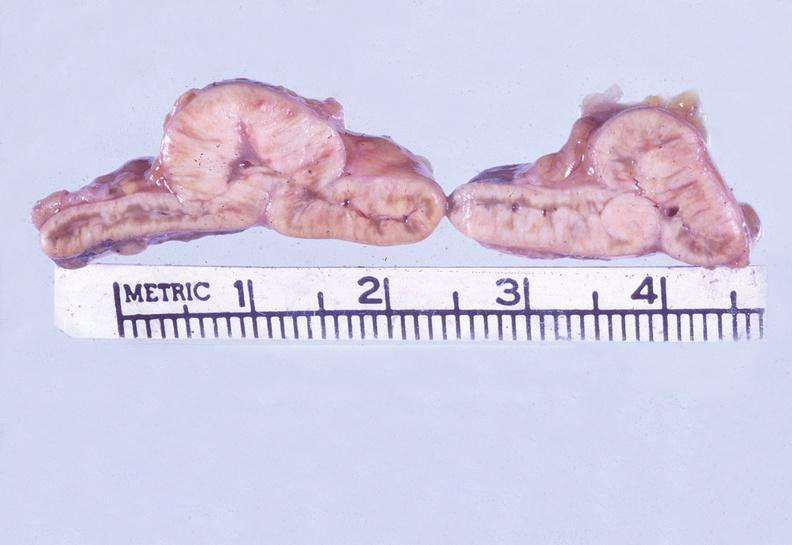does this image show adrenal, metastatic gastric carcinoma, diffuse?
Answer the question using a single word or phrase. Yes 